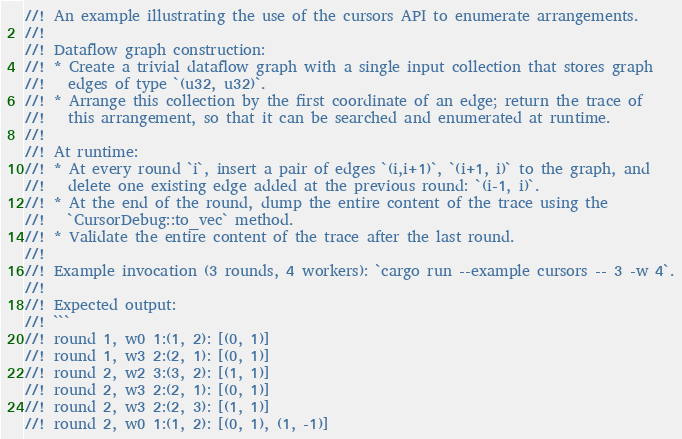<code> <loc_0><loc_0><loc_500><loc_500><_Rust_>//! An example illustrating the use of the cursors API to enumerate arrangements.
//!
//! Dataflow graph construction:
//! * Create a trivial dataflow graph with a single input collection that stores graph
//!   edges of type `(u32, u32)`.
//! * Arrange this collection by the first coordinate of an edge; return the trace of
//!   this arrangement, so that it can be searched and enumerated at runtime.
//!
//! At runtime:
//! * At every round `i`, insert a pair of edges `(i,i+1)`, `(i+1, i)` to the graph, and
//!   delete one existing edge added at the previous round: `(i-1, i)`.
//! * At the end of the round, dump the entire content of the trace using the
//!   `CursorDebug::to_vec` method.
//! * Validate the entire content of the trace after the last round.
//!
//! Example invocation (3 rounds, 4 workers): `cargo run --example cursors -- 3 -w 4`.
//!
//! Expected output:
//! ```
//! round 1, w0 1:(1, 2): [(0, 1)]
//! round 1, w3 2:(2, 1): [(0, 1)]
//! round 2, w2 3:(3, 2): [(1, 1)]
//! round 2, w3 2:(2, 1): [(0, 1)]
//! round 2, w3 2:(2, 3): [(1, 1)]
//! round 2, w0 1:(1, 2): [(0, 1), (1, -1)]</code> 